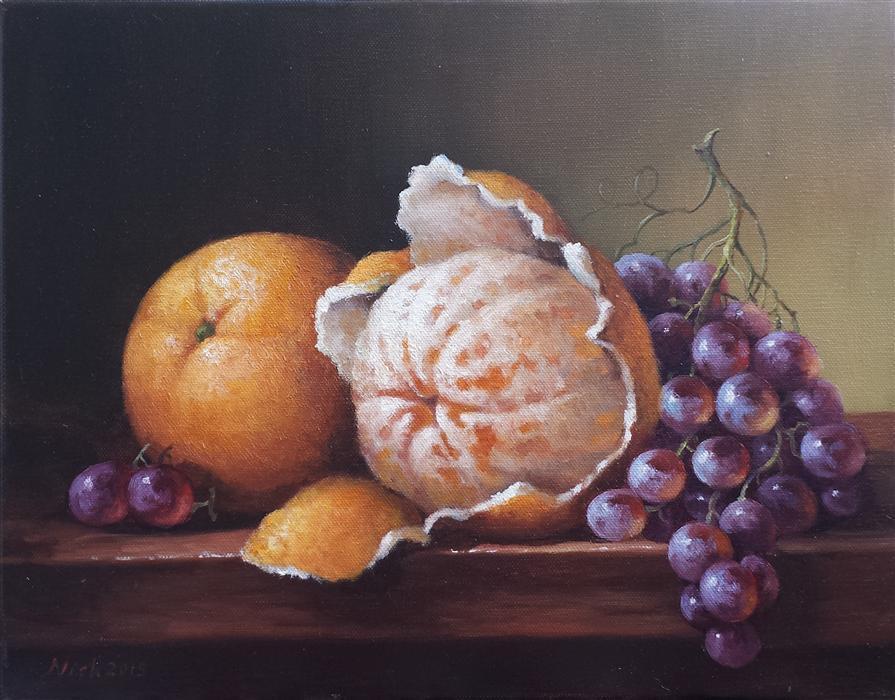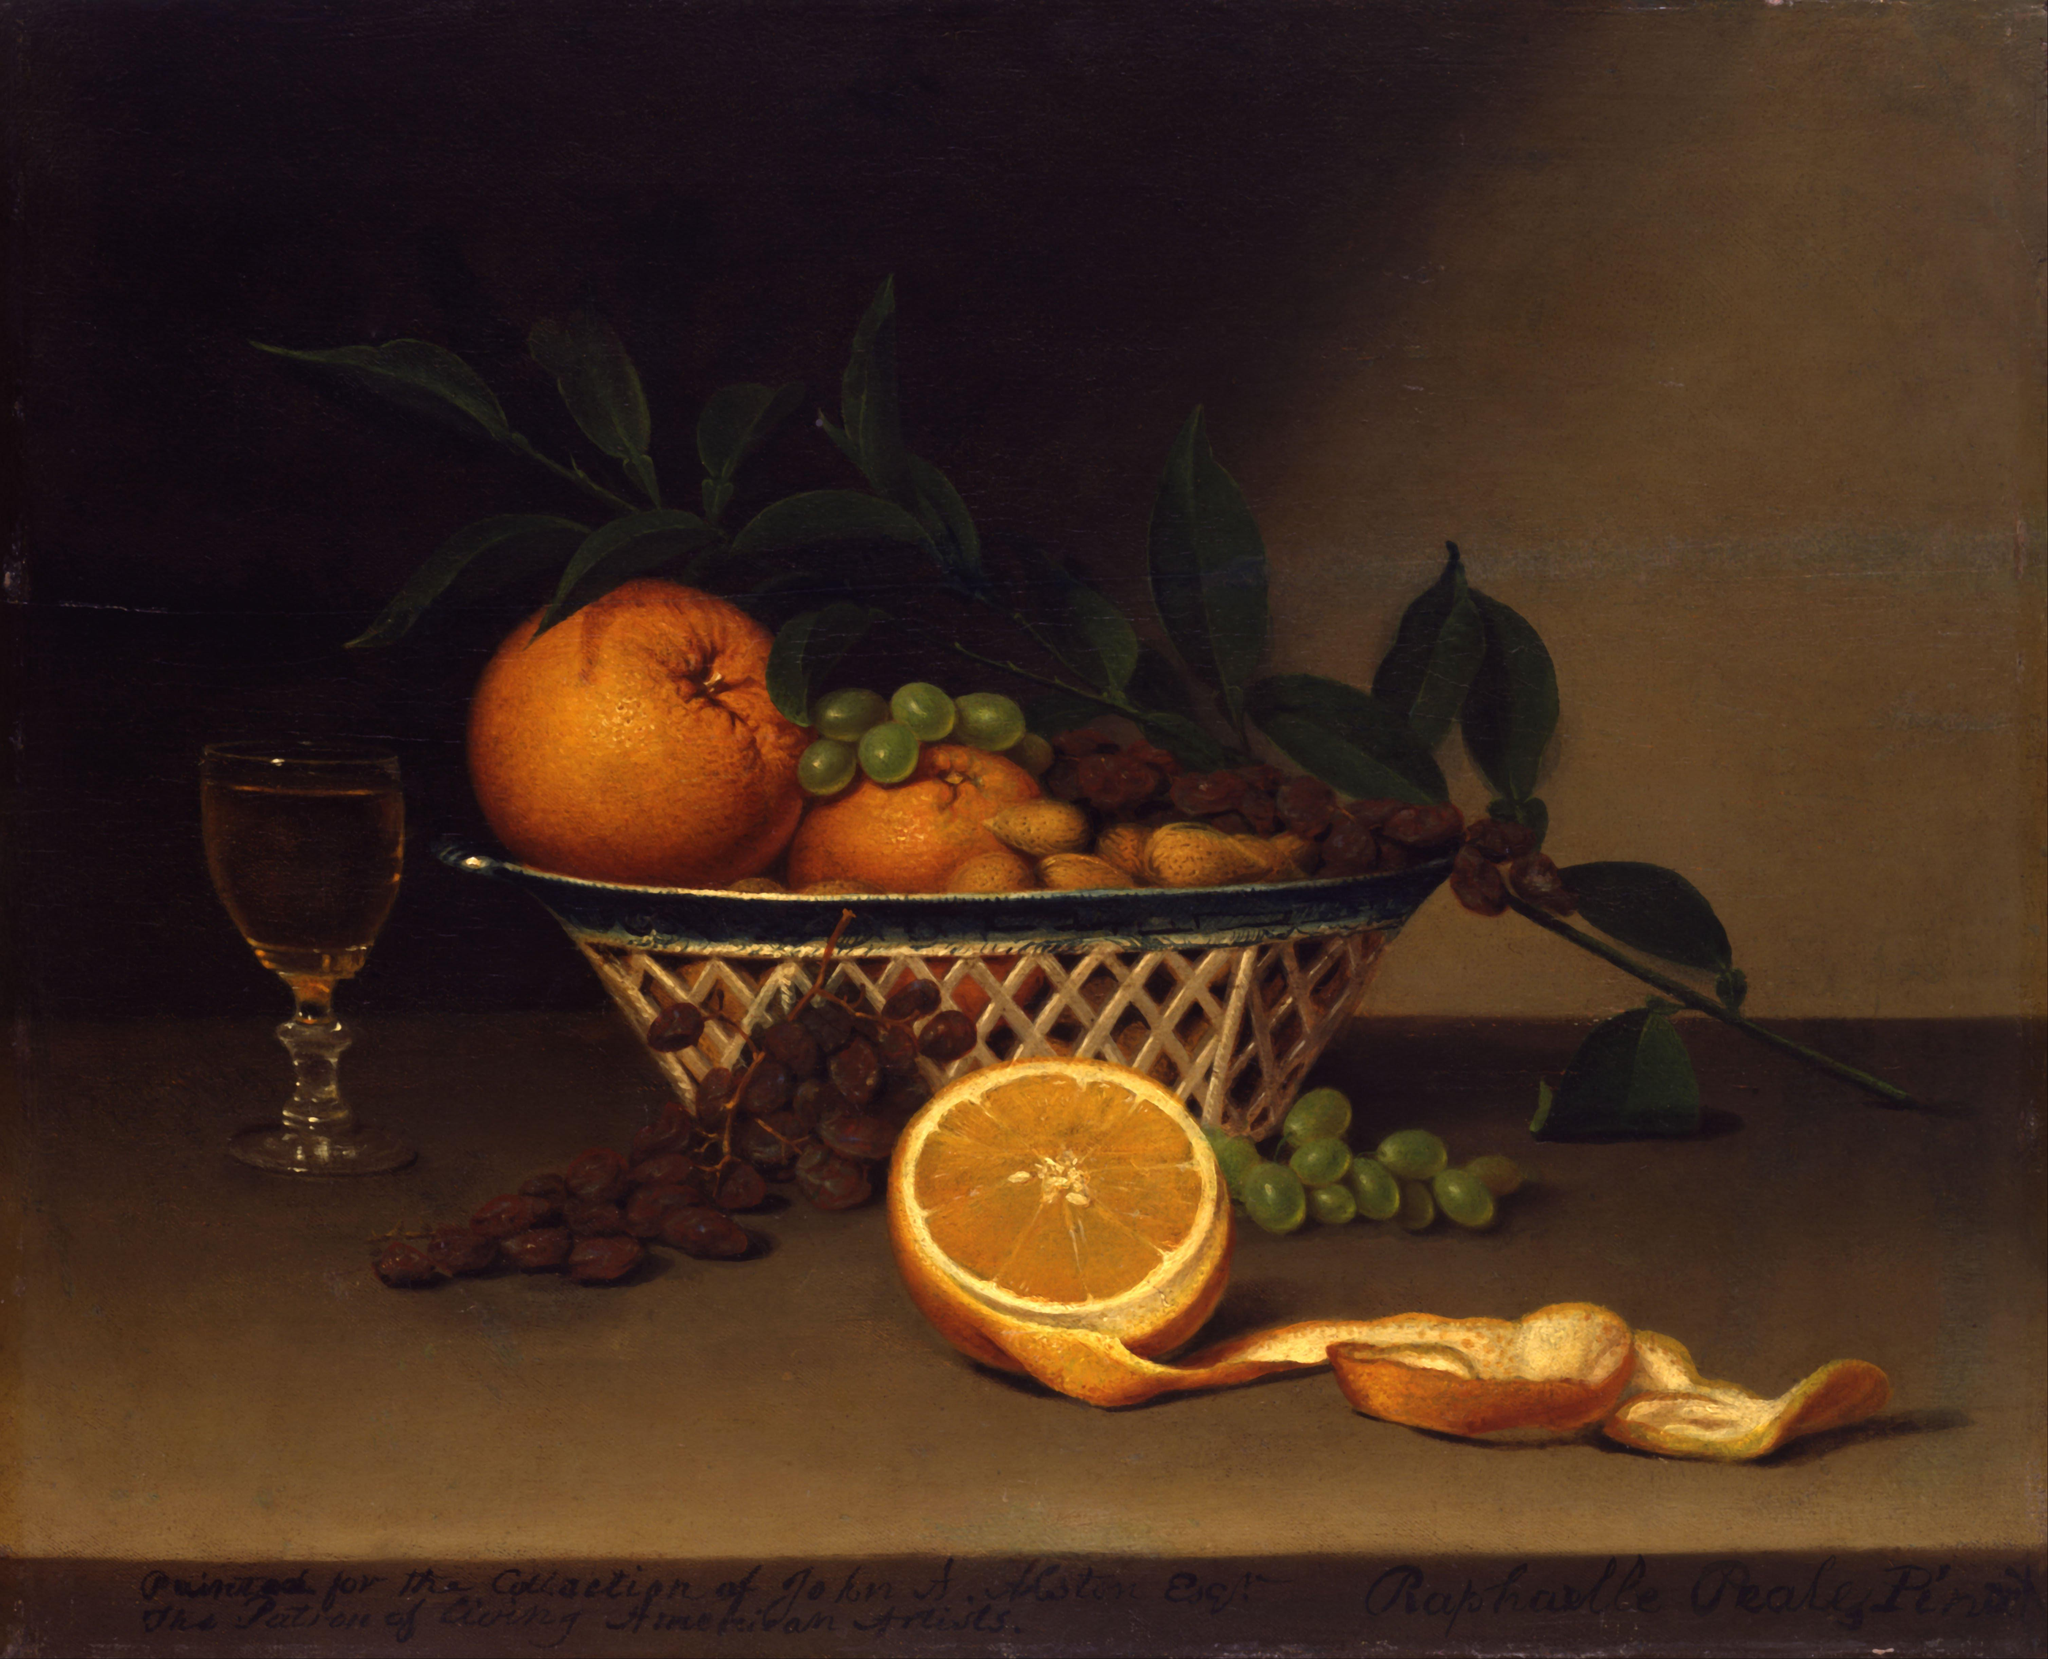The first image is the image on the left, the second image is the image on the right. Considering the images on both sides, is "In at least on of the images, bunches of grapes are sitting on a table near some oranges." valid? Answer yes or no. Yes. The first image is the image on the left, the second image is the image on the right. Evaluate the accuracy of this statement regarding the images: "One image shows a peeled orange with its peel loosely around it, in front of a bunch of grapes.". Is it true? Answer yes or no. Yes. 